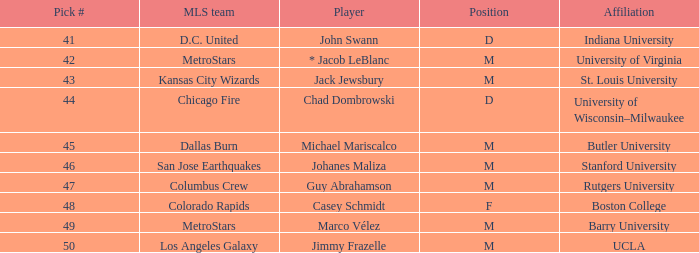What is the position of the Colorado Rapids team? F. 